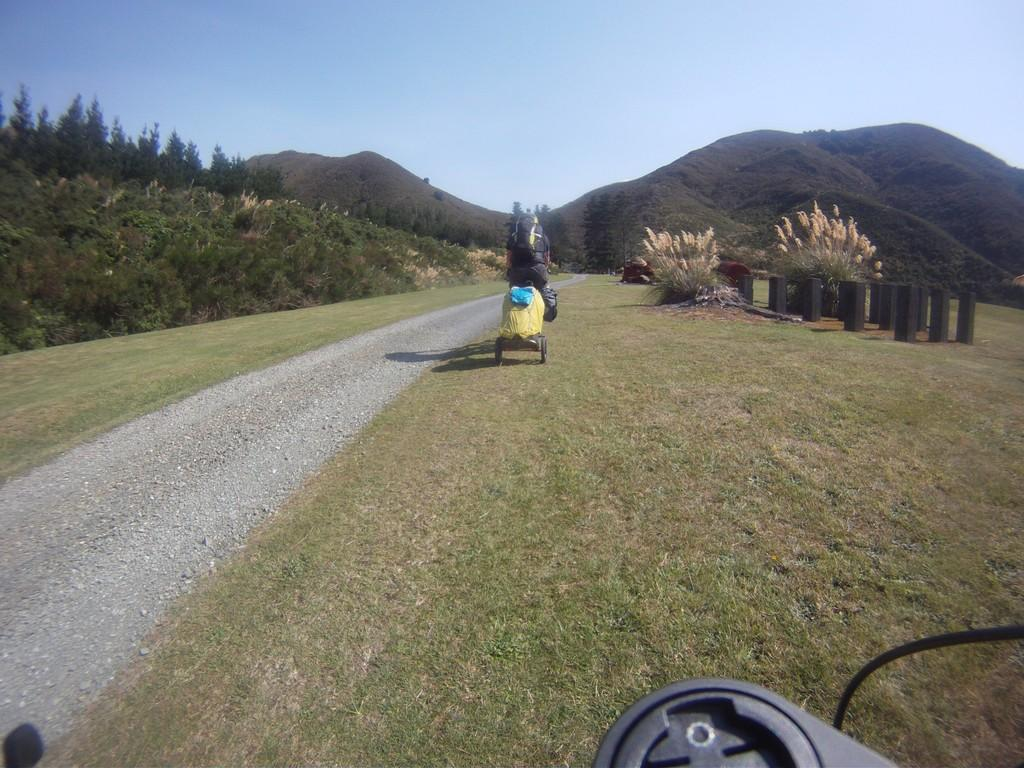What is the main object in the image? There is an object in the image, but its specific nature is not mentioned in the facts. What is the person doing in the image? A person is on a vehicle on the ground. What type of natural environment can be seen in the image? Trees are visible in the image, suggesting a forest or wooded area. What other objects are present in the image? There are some objects in the image, but their specific nature is not mentioned in the facts. What is visible in the background of the image? There are mountains and the sky visible in the background of the image. Can you see a goose swimming in the seashore in the image? There is no seashore or goose present in the image. Is there an oven visible in the image? There is no oven present in the image. 